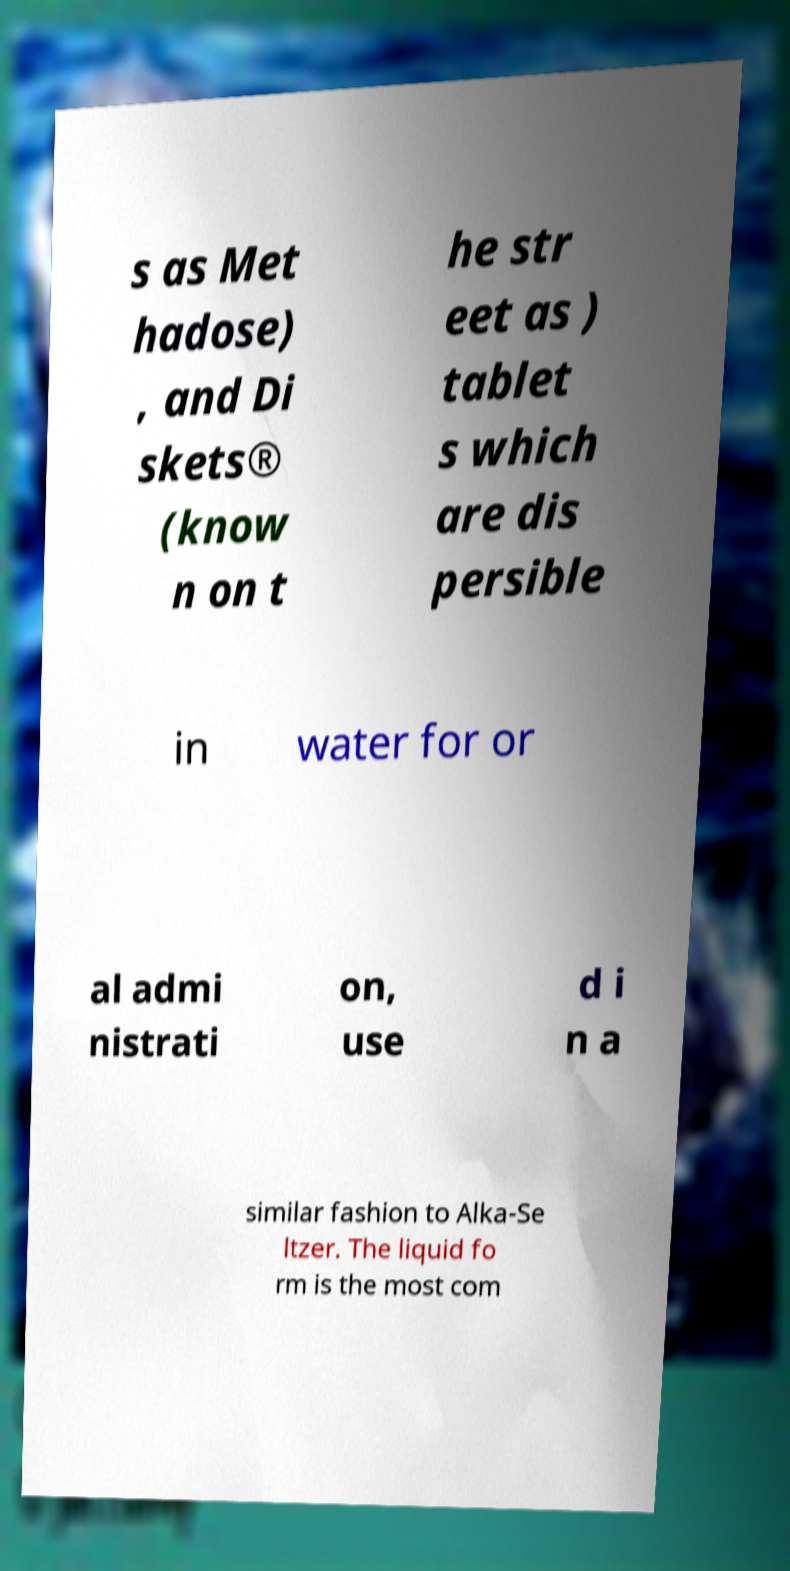What messages or text are displayed in this image? I need them in a readable, typed format. s as Met hadose) , and Di skets® (know n on t he str eet as ) tablet s which are dis persible in water for or al admi nistrati on, use d i n a similar fashion to Alka-Se ltzer. The liquid fo rm is the most com 